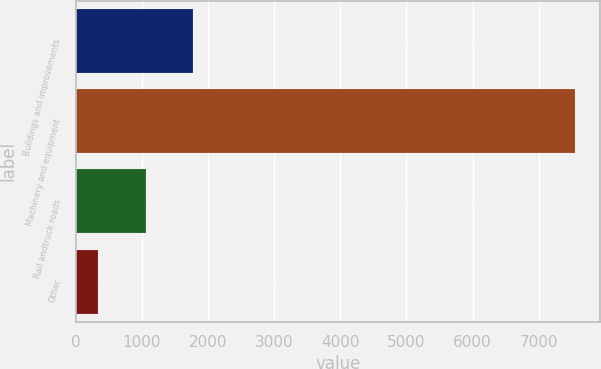Convert chart to OTSL. <chart><loc_0><loc_0><loc_500><loc_500><bar_chart><fcel>Buildings and improvements<fcel>Machinery and equipment<fcel>Rail andtruck roads<fcel>Other<nl><fcel>1777.8<fcel>7553<fcel>1055.9<fcel>334<nl></chart> 